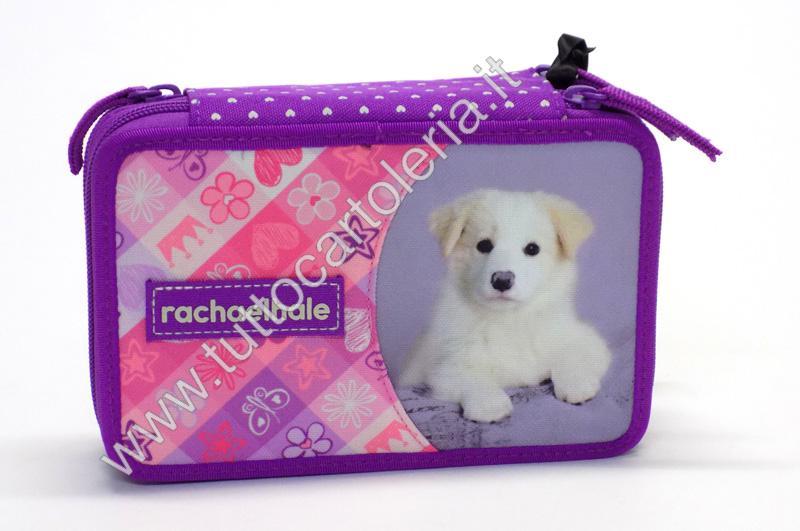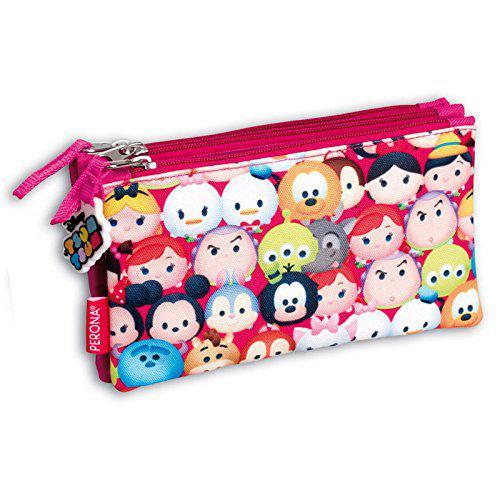The first image is the image on the left, the second image is the image on the right. Analyze the images presented: Is the assertion "There are writing utensils visible in one of the images." valid? Answer yes or no. No. The first image is the image on the left, the second image is the image on the right. Given the left and right images, does the statement "The case in one of the images is opened to reveal its contents." hold true? Answer yes or no. No. 